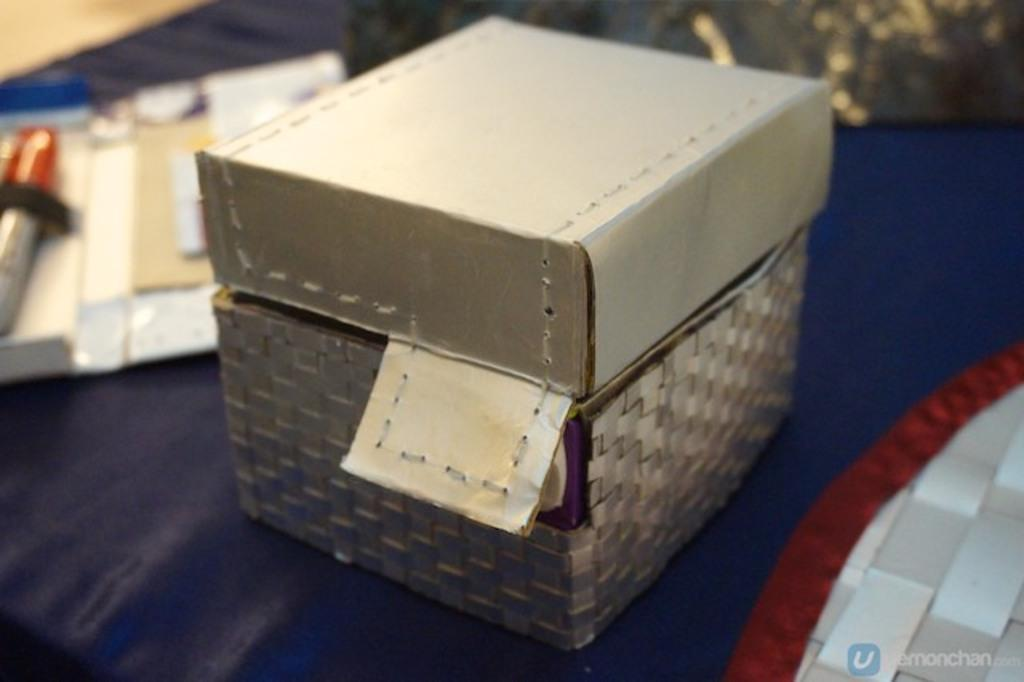What is the main object in the image? There is a table in the image. What is placed on the table? There is a box on the table. Can you describe the background of the image? The background of the image is blurred. What type of toy can be seen in the image? There is no toy present in the image; it only features a table and a box. 